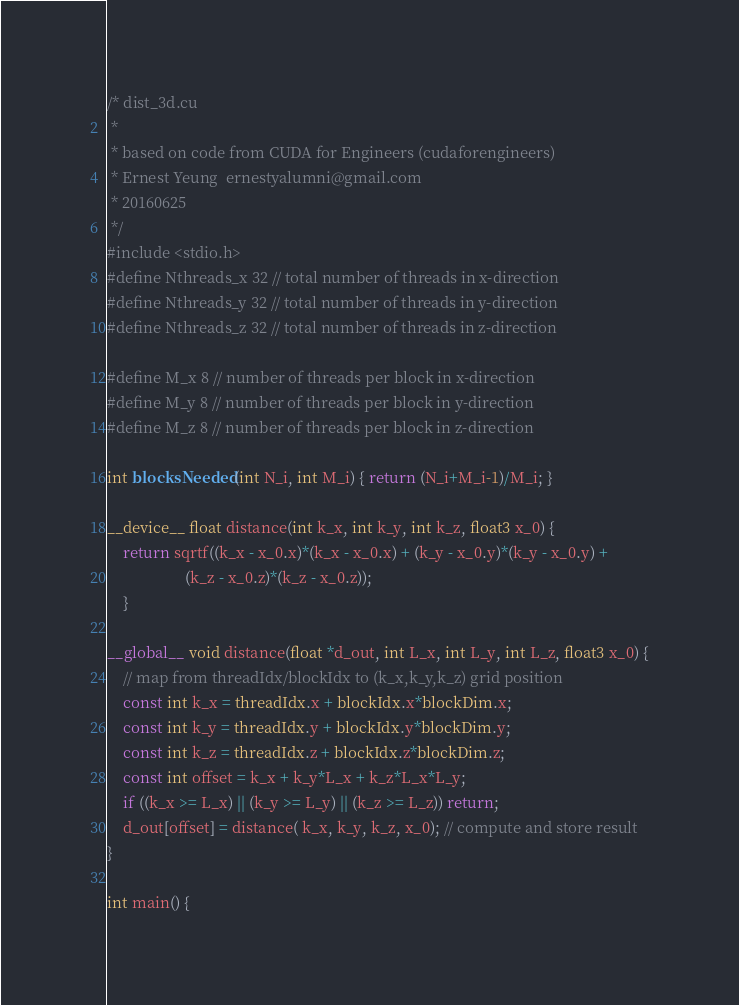Convert code to text. <code><loc_0><loc_0><loc_500><loc_500><_Cuda_>/* dist_3d.cu
 *  
 * based on code from CUDA for Engineers (cudaforengineers)
 * Ernest Yeung  ernestyalumni@gmail.com
 * 20160625
 */
#include <stdio.h>
#define Nthreads_x 32 // total number of threads in x-direction
#define Nthreads_y 32 // total number of threads in y-direction
#define Nthreads_z 32 // total number of threads in z-direction

#define M_x 8 // number of threads per block in x-direction
#define M_y 8 // number of threads per block in y-direction
#define M_z 8 // number of threads per block in z-direction

int blocksNeeded(int N_i, int M_i) { return (N_i+M_i-1)/M_i; }

__device__ float distance(int k_x, int k_y, int k_z, float3 x_0) {
	return sqrtf((k_x - x_0.x)*(k_x - x_0.x) + (k_y - x_0.y)*(k_y - x_0.y) + 
					(k_z - x_0.z)*(k_z - x_0.z));
	}

__global__ void distance(float *d_out, int L_x, int L_y, int L_z, float3 x_0) {
	// map from threadIdx/blockIdx to (k_x,k_y,k_z) grid position
	const int k_x = threadIdx.x + blockIdx.x*blockDim.x;
	const int k_y = threadIdx.y + blockIdx.y*blockDim.y;
	const int k_z = threadIdx.z + blockIdx.z*blockDim.z;
	const int offset = k_x + k_y*L_x + k_z*L_x*L_y;
	if ((k_x >= L_x) || (k_y >= L_y) || (k_z >= L_z)) return;
	d_out[offset] = distance( k_x, k_y, k_z, x_0); // compute and store result
}
	
int main() {</code> 